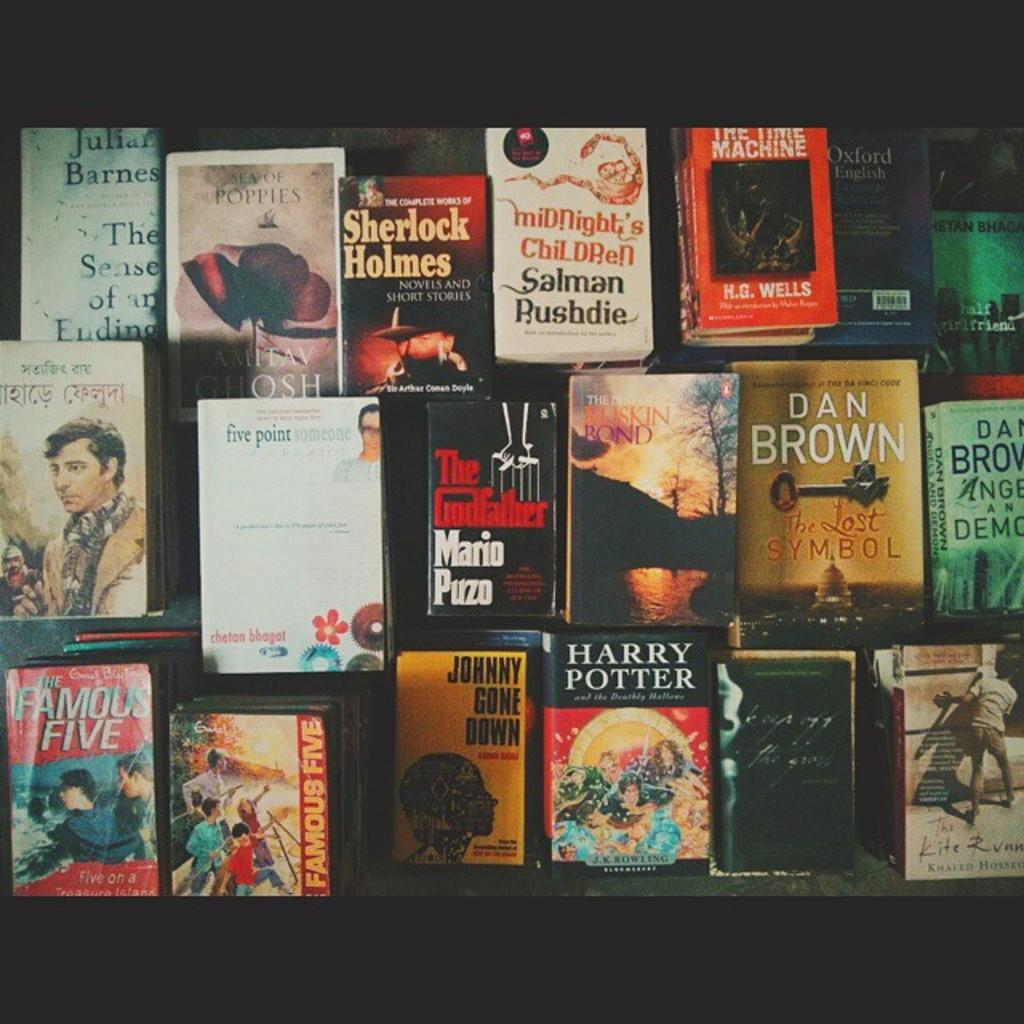<image>
Summarize the visual content of the image. A Dan Brown book is on display among other books 